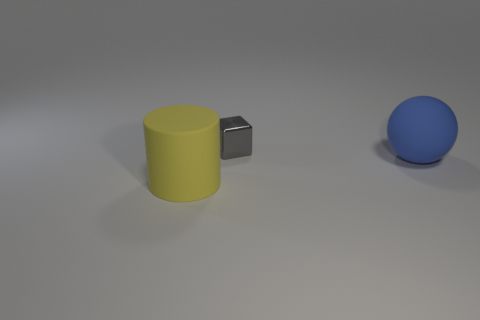Add 2 gray blocks. How many objects exist? 5 Subtract 0 brown blocks. How many objects are left? 3 Subtract all blocks. How many objects are left? 2 Subtract 1 balls. How many balls are left? 0 Subtract all big cylinders. Subtract all blue balls. How many objects are left? 1 Add 2 gray metal blocks. How many gray metal blocks are left? 3 Add 1 big green metallic cylinders. How many big green metallic cylinders exist? 1 